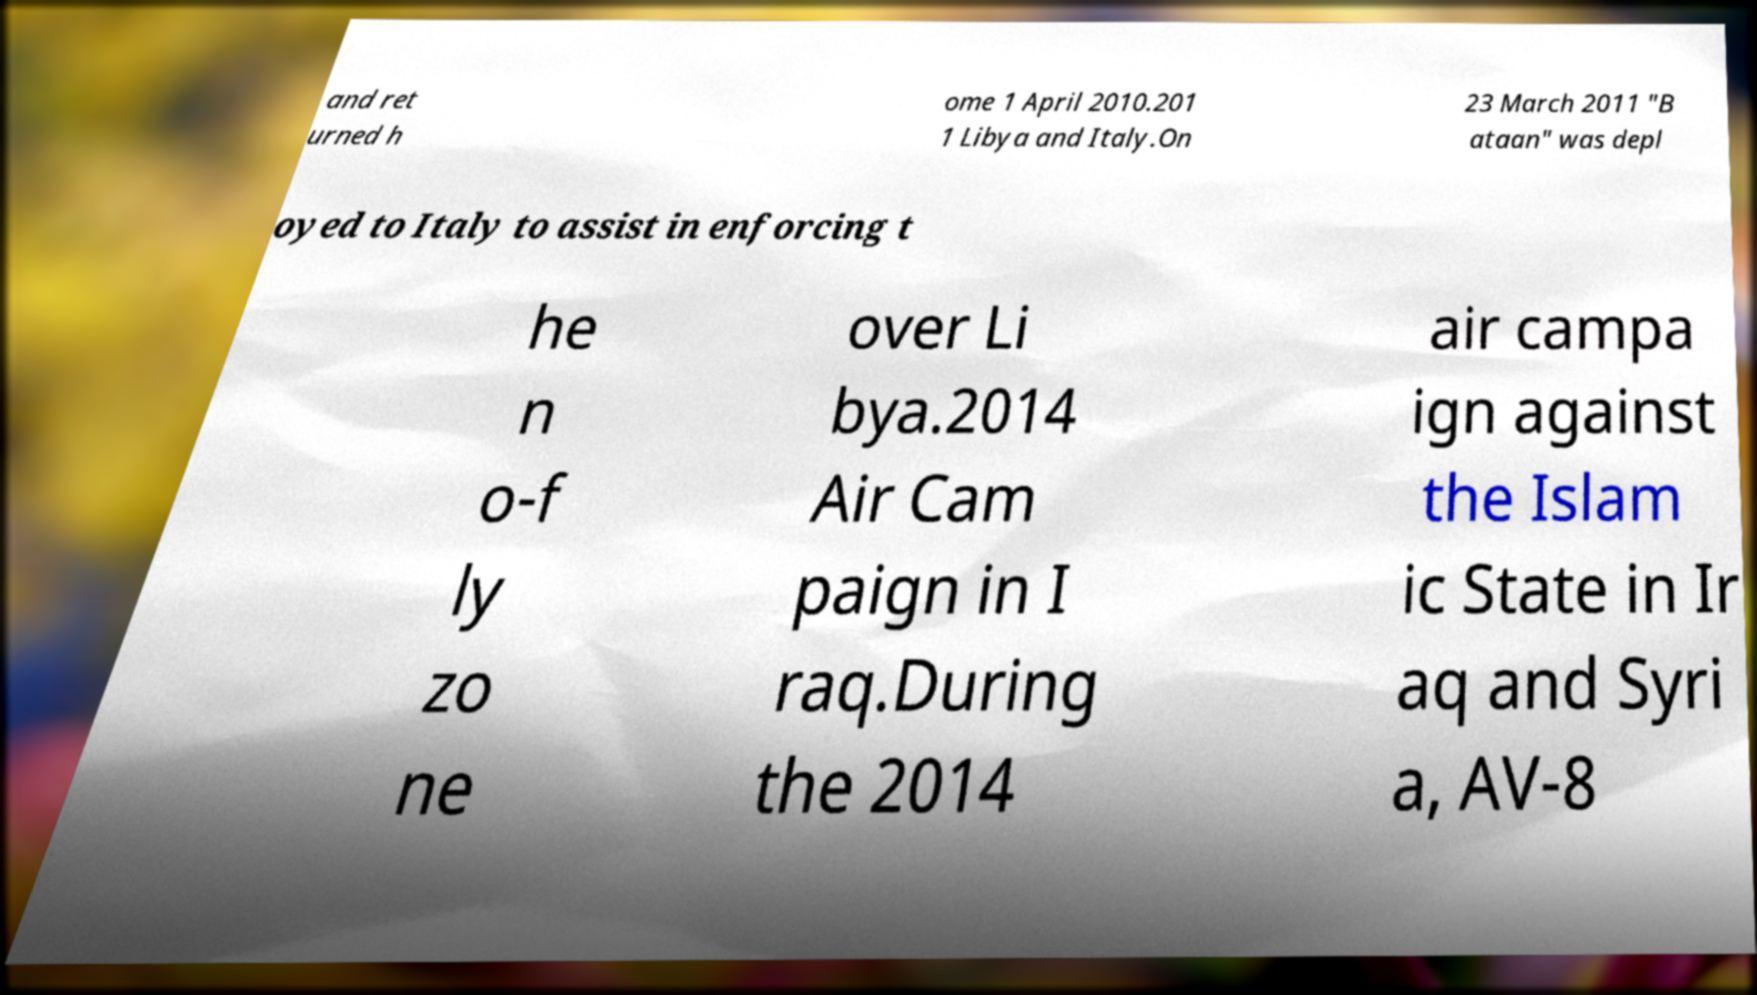There's text embedded in this image that I need extracted. Can you transcribe it verbatim? and ret urned h ome 1 April 2010.201 1 Libya and Italy.On 23 March 2011 "B ataan" was depl oyed to Italy to assist in enforcing t he n o-f ly zo ne over Li bya.2014 Air Cam paign in I raq.During the 2014 air campa ign against the Islam ic State in Ir aq and Syri a, AV-8 